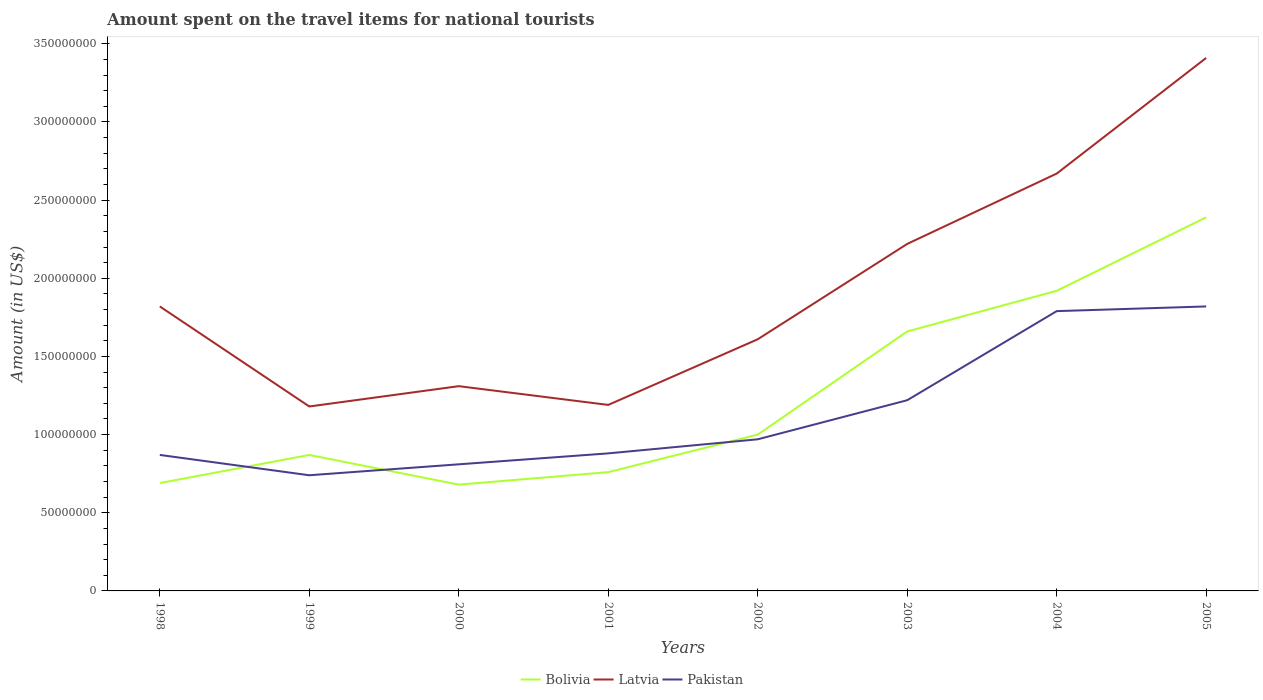Does the line corresponding to Bolivia intersect with the line corresponding to Pakistan?
Offer a very short reply. Yes. Is the number of lines equal to the number of legend labels?
Make the answer very short. Yes. Across all years, what is the maximum amount spent on the travel items for national tourists in Latvia?
Keep it short and to the point. 1.18e+08. What is the total amount spent on the travel items for national tourists in Latvia in the graph?
Offer a terse response. -4.30e+07. What is the difference between the highest and the second highest amount spent on the travel items for national tourists in Pakistan?
Ensure brevity in your answer.  1.08e+08. What is the difference between the highest and the lowest amount spent on the travel items for national tourists in Bolivia?
Your response must be concise. 3. How many lines are there?
Your response must be concise. 3. How many years are there in the graph?
Your response must be concise. 8. How many legend labels are there?
Your answer should be very brief. 3. What is the title of the graph?
Keep it short and to the point. Amount spent on the travel items for national tourists. What is the label or title of the X-axis?
Give a very brief answer. Years. What is the Amount (in US$) in Bolivia in 1998?
Your response must be concise. 6.90e+07. What is the Amount (in US$) in Latvia in 1998?
Make the answer very short. 1.82e+08. What is the Amount (in US$) of Pakistan in 1998?
Make the answer very short. 8.70e+07. What is the Amount (in US$) in Bolivia in 1999?
Your answer should be very brief. 8.70e+07. What is the Amount (in US$) of Latvia in 1999?
Your answer should be compact. 1.18e+08. What is the Amount (in US$) in Pakistan in 1999?
Your answer should be very brief. 7.40e+07. What is the Amount (in US$) in Bolivia in 2000?
Provide a short and direct response. 6.80e+07. What is the Amount (in US$) in Latvia in 2000?
Your response must be concise. 1.31e+08. What is the Amount (in US$) of Pakistan in 2000?
Provide a succinct answer. 8.10e+07. What is the Amount (in US$) in Bolivia in 2001?
Your response must be concise. 7.60e+07. What is the Amount (in US$) of Latvia in 2001?
Provide a short and direct response. 1.19e+08. What is the Amount (in US$) in Pakistan in 2001?
Offer a very short reply. 8.80e+07. What is the Amount (in US$) of Latvia in 2002?
Give a very brief answer. 1.61e+08. What is the Amount (in US$) in Pakistan in 2002?
Provide a succinct answer. 9.70e+07. What is the Amount (in US$) of Bolivia in 2003?
Your response must be concise. 1.66e+08. What is the Amount (in US$) of Latvia in 2003?
Offer a very short reply. 2.22e+08. What is the Amount (in US$) of Pakistan in 2003?
Provide a short and direct response. 1.22e+08. What is the Amount (in US$) in Bolivia in 2004?
Offer a very short reply. 1.92e+08. What is the Amount (in US$) of Latvia in 2004?
Your answer should be compact. 2.67e+08. What is the Amount (in US$) in Pakistan in 2004?
Provide a succinct answer. 1.79e+08. What is the Amount (in US$) of Bolivia in 2005?
Your answer should be compact. 2.39e+08. What is the Amount (in US$) of Latvia in 2005?
Your response must be concise. 3.41e+08. What is the Amount (in US$) in Pakistan in 2005?
Offer a very short reply. 1.82e+08. Across all years, what is the maximum Amount (in US$) in Bolivia?
Give a very brief answer. 2.39e+08. Across all years, what is the maximum Amount (in US$) in Latvia?
Your response must be concise. 3.41e+08. Across all years, what is the maximum Amount (in US$) in Pakistan?
Your response must be concise. 1.82e+08. Across all years, what is the minimum Amount (in US$) in Bolivia?
Provide a short and direct response. 6.80e+07. Across all years, what is the minimum Amount (in US$) in Latvia?
Provide a succinct answer. 1.18e+08. Across all years, what is the minimum Amount (in US$) of Pakistan?
Make the answer very short. 7.40e+07. What is the total Amount (in US$) of Bolivia in the graph?
Your response must be concise. 9.97e+08. What is the total Amount (in US$) in Latvia in the graph?
Ensure brevity in your answer.  1.54e+09. What is the total Amount (in US$) in Pakistan in the graph?
Provide a succinct answer. 9.10e+08. What is the difference between the Amount (in US$) of Bolivia in 1998 and that in 1999?
Provide a short and direct response. -1.80e+07. What is the difference between the Amount (in US$) of Latvia in 1998 and that in 1999?
Make the answer very short. 6.40e+07. What is the difference between the Amount (in US$) of Pakistan in 1998 and that in 1999?
Provide a short and direct response. 1.30e+07. What is the difference between the Amount (in US$) in Bolivia in 1998 and that in 2000?
Ensure brevity in your answer.  1.00e+06. What is the difference between the Amount (in US$) of Latvia in 1998 and that in 2000?
Your answer should be very brief. 5.10e+07. What is the difference between the Amount (in US$) in Bolivia in 1998 and that in 2001?
Make the answer very short. -7.00e+06. What is the difference between the Amount (in US$) of Latvia in 1998 and that in 2001?
Ensure brevity in your answer.  6.30e+07. What is the difference between the Amount (in US$) in Pakistan in 1998 and that in 2001?
Make the answer very short. -1.00e+06. What is the difference between the Amount (in US$) in Bolivia in 1998 and that in 2002?
Provide a succinct answer. -3.10e+07. What is the difference between the Amount (in US$) in Latvia in 1998 and that in 2002?
Make the answer very short. 2.10e+07. What is the difference between the Amount (in US$) in Pakistan in 1998 and that in 2002?
Offer a terse response. -1.00e+07. What is the difference between the Amount (in US$) in Bolivia in 1998 and that in 2003?
Keep it short and to the point. -9.70e+07. What is the difference between the Amount (in US$) of Latvia in 1998 and that in 2003?
Provide a succinct answer. -4.00e+07. What is the difference between the Amount (in US$) in Pakistan in 1998 and that in 2003?
Offer a terse response. -3.50e+07. What is the difference between the Amount (in US$) of Bolivia in 1998 and that in 2004?
Your response must be concise. -1.23e+08. What is the difference between the Amount (in US$) of Latvia in 1998 and that in 2004?
Keep it short and to the point. -8.50e+07. What is the difference between the Amount (in US$) in Pakistan in 1998 and that in 2004?
Your answer should be compact. -9.20e+07. What is the difference between the Amount (in US$) in Bolivia in 1998 and that in 2005?
Give a very brief answer. -1.70e+08. What is the difference between the Amount (in US$) in Latvia in 1998 and that in 2005?
Keep it short and to the point. -1.59e+08. What is the difference between the Amount (in US$) of Pakistan in 1998 and that in 2005?
Offer a terse response. -9.50e+07. What is the difference between the Amount (in US$) in Bolivia in 1999 and that in 2000?
Keep it short and to the point. 1.90e+07. What is the difference between the Amount (in US$) in Latvia in 1999 and that in 2000?
Your answer should be compact. -1.30e+07. What is the difference between the Amount (in US$) in Pakistan in 1999 and that in 2000?
Keep it short and to the point. -7.00e+06. What is the difference between the Amount (in US$) of Bolivia in 1999 and that in 2001?
Your response must be concise. 1.10e+07. What is the difference between the Amount (in US$) of Latvia in 1999 and that in 2001?
Offer a terse response. -1.00e+06. What is the difference between the Amount (in US$) in Pakistan in 1999 and that in 2001?
Make the answer very short. -1.40e+07. What is the difference between the Amount (in US$) in Bolivia in 1999 and that in 2002?
Ensure brevity in your answer.  -1.30e+07. What is the difference between the Amount (in US$) of Latvia in 1999 and that in 2002?
Give a very brief answer. -4.30e+07. What is the difference between the Amount (in US$) of Pakistan in 1999 and that in 2002?
Your answer should be compact. -2.30e+07. What is the difference between the Amount (in US$) in Bolivia in 1999 and that in 2003?
Your answer should be very brief. -7.90e+07. What is the difference between the Amount (in US$) in Latvia in 1999 and that in 2003?
Your answer should be compact. -1.04e+08. What is the difference between the Amount (in US$) in Pakistan in 1999 and that in 2003?
Your answer should be very brief. -4.80e+07. What is the difference between the Amount (in US$) of Bolivia in 1999 and that in 2004?
Give a very brief answer. -1.05e+08. What is the difference between the Amount (in US$) of Latvia in 1999 and that in 2004?
Your answer should be very brief. -1.49e+08. What is the difference between the Amount (in US$) of Pakistan in 1999 and that in 2004?
Offer a very short reply. -1.05e+08. What is the difference between the Amount (in US$) of Bolivia in 1999 and that in 2005?
Ensure brevity in your answer.  -1.52e+08. What is the difference between the Amount (in US$) of Latvia in 1999 and that in 2005?
Ensure brevity in your answer.  -2.23e+08. What is the difference between the Amount (in US$) of Pakistan in 1999 and that in 2005?
Make the answer very short. -1.08e+08. What is the difference between the Amount (in US$) of Bolivia in 2000 and that in 2001?
Offer a very short reply. -8.00e+06. What is the difference between the Amount (in US$) of Latvia in 2000 and that in 2001?
Provide a short and direct response. 1.20e+07. What is the difference between the Amount (in US$) in Pakistan in 2000 and that in 2001?
Make the answer very short. -7.00e+06. What is the difference between the Amount (in US$) of Bolivia in 2000 and that in 2002?
Ensure brevity in your answer.  -3.20e+07. What is the difference between the Amount (in US$) of Latvia in 2000 and that in 2002?
Ensure brevity in your answer.  -3.00e+07. What is the difference between the Amount (in US$) of Pakistan in 2000 and that in 2002?
Provide a short and direct response. -1.60e+07. What is the difference between the Amount (in US$) in Bolivia in 2000 and that in 2003?
Give a very brief answer. -9.80e+07. What is the difference between the Amount (in US$) in Latvia in 2000 and that in 2003?
Provide a succinct answer. -9.10e+07. What is the difference between the Amount (in US$) in Pakistan in 2000 and that in 2003?
Give a very brief answer. -4.10e+07. What is the difference between the Amount (in US$) in Bolivia in 2000 and that in 2004?
Your answer should be very brief. -1.24e+08. What is the difference between the Amount (in US$) of Latvia in 2000 and that in 2004?
Your response must be concise. -1.36e+08. What is the difference between the Amount (in US$) in Pakistan in 2000 and that in 2004?
Your response must be concise. -9.80e+07. What is the difference between the Amount (in US$) in Bolivia in 2000 and that in 2005?
Your answer should be very brief. -1.71e+08. What is the difference between the Amount (in US$) of Latvia in 2000 and that in 2005?
Offer a very short reply. -2.10e+08. What is the difference between the Amount (in US$) of Pakistan in 2000 and that in 2005?
Keep it short and to the point. -1.01e+08. What is the difference between the Amount (in US$) in Bolivia in 2001 and that in 2002?
Provide a succinct answer. -2.40e+07. What is the difference between the Amount (in US$) in Latvia in 2001 and that in 2002?
Make the answer very short. -4.20e+07. What is the difference between the Amount (in US$) in Pakistan in 2001 and that in 2002?
Ensure brevity in your answer.  -9.00e+06. What is the difference between the Amount (in US$) in Bolivia in 2001 and that in 2003?
Your answer should be compact. -9.00e+07. What is the difference between the Amount (in US$) in Latvia in 2001 and that in 2003?
Make the answer very short. -1.03e+08. What is the difference between the Amount (in US$) in Pakistan in 2001 and that in 2003?
Make the answer very short. -3.40e+07. What is the difference between the Amount (in US$) in Bolivia in 2001 and that in 2004?
Offer a terse response. -1.16e+08. What is the difference between the Amount (in US$) of Latvia in 2001 and that in 2004?
Your response must be concise. -1.48e+08. What is the difference between the Amount (in US$) in Pakistan in 2001 and that in 2004?
Offer a terse response. -9.10e+07. What is the difference between the Amount (in US$) in Bolivia in 2001 and that in 2005?
Provide a short and direct response. -1.63e+08. What is the difference between the Amount (in US$) of Latvia in 2001 and that in 2005?
Offer a very short reply. -2.22e+08. What is the difference between the Amount (in US$) in Pakistan in 2001 and that in 2005?
Make the answer very short. -9.40e+07. What is the difference between the Amount (in US$) in Bolivia in 2002 and that in 2003?
Provide a succinct answer. -6.60e+07. What is the difference between the Amount (in US$) of Latvia in 2002 and that in 2003?
Offer a very short reply. -6.10e+07. What is the difference between the Amount (in US$) in Pakistan in 2002 and that in 2003?
Provide a succinct answer. -2.50e+07. What is the difference between the Amount (in US$) in Bolivia in 2002 and that in 2004?
Your answer should be very brief. -9.20e+07. What is the difference between the Amount (in US$) in Latvia in 2002 and that in 2004?
Provide a short and direct response. -1.06e+08. What is the difference between the Amount (in US$) of Pakistan in 2002 and that in 2004?
Your response must be concise. -8.20e+07. What is the difference between the Amount (in US$) in Bolivia in 2002 and that in 2005?
Provide a short and direct response. -1.39e+08. What is the difference between the Amount (in US$) of Latvia in 2002 and that in 2005?
Your answer should be compact. -1.80e+08. What is the difference between the Amount (in US$) in Pakistan in 2002 and that in 2005?
Keep it short and to the point. -8.50e+07. What is the difference between the Amount (in US$) in Bolivia in 2003 and that in 2004?
Your response must be concise. -2.60e+07. What is the difference between the Amount (in US$) of Latvia in 2003 and that in 2004?
Give a very brief answer. -4.50e+07. What is the difference between the Amount (in US$) in Pakistan in 2003 and that in 2004?
Your answer should be compact. -5.70e+07. What is the difference between the Amount (in US$) in Bolivia in 2003 and that in 2005?
Offer a very short reply. -7.30e+07. What is the difference between the Amount (in US$) in Latvia in 2003 and that in 2005?
Give a very brief answer. -1.19e+08. What is the difference between the Amount (in US$) of Pakistan in 2003 and that in 2005?
Give a very brief answer. -6.00e+07. What is the difference between the Amount (in US$) of Bolivia in 2004 and that in 2005?
Your answer should be compact. -4.70e+07. What is the difference between the Amount (in US$) of Latvia in 2004 and that in 2005?
Your response must be concise. -7.40e+07. What is the difference between the Amount (in US$) in Pakistan in 2004 and that in 2005?
Make the answer very short. -3.00e+06. What is the difference between the Amount (in US$) in Bolivia in 1998 and the Amount (in US$) in Latvia in 1999?
Your answer should be compact. -4.90e+07. What is the difference between the Amount (in US$) in Bolivia in 1998 and the Amount (in US$) in Pakistan in 1999?
Ensure brevity in your answer.  -5.00e+06. What is the difference between the Amount (in US$) in Latvia in 1998 and the Amount (in US$) in Pakistan in 1999?
Your answer should be very brief. 1.08e+08. What is the difference between the Amount (in US$) in Bolivia in 1998 and the Amount (in US$) in Latvia in 2000?
Make the answer very short. -6.20e+07. What is the difference between the Amount (in US$) of Bolivia in 1998 and the Amount (in US$) of Pakistan in 2000?
Make the answer very short. -1.20e+07. What is the difference between the Amount (in US$) of Latvia in 1998 and the Amount (in US$) of Pakistan in 2000?
Your answer should be compact. 1.01e+08. What is the difference between the Amount (in US$) in Bolivia in 1998 and the Amount (in US$) in Latvia in 2001?
Your answer should be very brief. -5.00e+07. What is the difference between the Amount (in US$) in Bolivia in 1998 and the Amount (in US$) in Pakistan in 2001?
Provide a succinct answer. -1.90e+07. What is the difference between the Amount (in US$) in Latvia in 1998 and the Amount (in US$) in Pakistan in 2001?
Provide a short and direct response. 9.40e+07. What is the difference between the Amount (in US$) in Bolivia in 1998 and the Amount (in US$) in Latvia in 2002?
Provide a short and direct response. -9.20e+07. What is the difference between the Amount (in US$) in Bolivia in 1998 and the Amount (in US$) in Pakistan in 2002?
Your answer should be compact. -2.80e+07. What is the difference between the Amount (in US$) of Latvia in 1998 and the Amount (in US$) of Pakistan in 2002?
Your answer should be compact. 8.50e+07. What is the difference between the Amount (in US$) in Bolivia in 1998 and the Amount (in US$) in Latvia in 2003?
Provide a succinct answer. -1.53e+08. What is the difference between the Amount (in US$) in Bolivia in 1998 and the Amount (in US$) in Pakistan in 2003?
Give a very brief answer. -5.30e+07. What is the difference between the Amount (in US$) of Latvia in 1998 and the Amount (in US$) of Pakistan in 2003?
Your answer should be very brief. 6.00e+07. What is the difference between the Amount (in US$) in Bolivia in 1998 and the Amount (in US$) in Latvia in 2004?
Your response must be concise. -1.98e+08. What is the difference between the Amount (in US$) of Bolivia in 1998 and the Amount (in US$) of Pakistan in 2004?
Provide a short and direct response. -1.10e+08. What is the difference between the Amount (in US$) in Bolivia in 1998 and the Amount (in US$) in Latvia in 2005?
Provide a short and direct response. -2.72e+08. What is the difference between the Amount (in US$) in Bolivia in 1998 and the Amount (in US$) in Pakistan in 2005?
Make the answer very short. -1.13e+08. What is the difference between the Amount (in US$) in Latvia in 1998 and the Amount (in US$) in Pakistan in 2005?
Your answer should be compact. 0. What is the difference between the Amount (in US$) in Bolivia in 1999 and the Amount (in US$) in Latvia in 2000?
Make the answer very short. -4.40e+07. What is the difference between the Amount (in US$) in Latvia in 1999 and the Amount (in US$) in Pakistan in 2000?
Your answer should be very brief. 3.70e+07. What is the difference between the Amount (in US$) in Bolivia in 1999 and the Amount (in US$) in Latvia in 2001?
Offer a very short reply. -3.20e+07. What is the difference between the Amount (in US$) in Latvia in 1999 and the Amount (in US$) in Pakistan in 2001?
Your answer should be very brief. 3.00e+07. What is the difference between the Amount (in US$) in Bolivia in 1999 and the Amount (in US$) in Latvia in 2002?
Give a very brief answer. -7.40e+07. What is the difference between the Amount (in US$) in Bolivia in 1999 and the Amount (in US$) in Pakistan in 2002?
Make the answer very short. -1.00e+07. What is the difference between the Amount (in US$) in Latvia in 1999 and the Amount (in US$) in Pakistan in 2002?
Offer a very short reply. 2.10e+07. What is the difference between the Amount (in US$) of Bolivia in 1999 and the Amount (in US$) of Latvia in 2003?
Ensure brevity in your answer.  -1.35e+08. What is the difference between the Amount (in US$) in Bolivia in 1999 and the Amount (in US$) in Pakistan in 2003?
Your answer should be very brief. -3.50e+07. What is the difference between the Amount (in US$) of Latvia in 1999 and the Amount (in US$) of Pakistan in 2003?
Your answer should be very brief. -4.00e+06. What is the difference between the Amount (in US$) in Bolivia in 1999 and the Amount (in US$) in Latvia in 2004?
Your response must be concise. -1.80e+08. What is the difference between the Amount (in US$) in Bolivia in 1999 and the Amount (in US$) in Pakistan in 2004?
Keep it short and to the point. -9.20e+07. What is the difference between the Amount (in US$) of Latvia in 1999 and the Amount (in US$) of Pakistan in 2004?
Offer a very short reply. -6.10e+07. What is the difference between the Amount (in US$) in Bolivia in 1999 and the Amount (in US$) in Latvia in 2005?
Your response must be concise. -2.54e+08. What is the difference between the Amount (in US$) of Bolivia in 1999 and the Amount (in US$) of Pakistan in 2005?
Give a very brief answer. -9.50e+07. What is the difference between the Amount (in US$) in Latvia in 1999 and the Amount (in US$) in Pakistan in 2005?
Offer a terse response. -6.40e+07. What is the difference between the Amount (in US$) in Bolivia in 2000 and the Amount (in US$) in Latvia in 2001?
Provide a short and direct response. -5.10e+07. What is the difference between the Amount (in US$) in Bolivia in 2000 and the Amount (in US$) in Pakistan in 2001?
Provide a succinct answer. -2.00e+07. What is the difference between the Amount (in US$) in Latvia in 2000 and the Amount (in US$) in Pakistan in 2001?
Provide a succinct answer. 4.30e+07. What is the difference between the Amount (in US$) in Bolivia in 2000 and the Amount (in US$) in Latvia in 2002?
Ensure brevity in your answer.  -9.30e+07. What is the difference between the Amount (in US$) of Bolivia in 2000 and the Amount (in US$) of Pakistan in 2002?
Keep it short and to the point. -2.90e+07. What is the difference between the Amount (in US$) of Latvia in 2000 and the Amount (in US$) of Pakistan in 2002?
Offer a very short reply. 3.40e+07. What is the difference between the Amount (in US$) in Bolivia in 2000 and the Amount (in US$) in Latvia in 2003?
Make the answer very short. -1.54e+08. What is the difference between the Amount (in US$) of Bolivia in 2000 and the Amount (in US$) of Pakistan in 2003?
Keep it short and to the point. -5.40e+07. What is the difference between the Amount (in US$) in Latvia in 2000 and the Amount (in US$) in Pakistan in 2003?
Give a very brief answer. 9.00e+06. What is the difference between the Amount (in US$) of Bolivia in 2000 and the Amount (in US$) of Latvia in 2004?
Your answer should be compact. -1.99e+08. What is the difference between the Amount (in US$) in Bolivia in 2000 and the Amount (in US$) in Pakistan in 2004?
Ensure brevity in your answer.  -1.11e+08. What is the difference between the Amount (in US$) of Latvia in 2000 and the Amount (in US$) of Pakistan in 2004?
Your answer should be compact. -4.80e+07. What is the difference between the Amount (in US$) in Bolivia in 2000 and the Amount (in US$) in Latvia in 2005?
Offer a terse response. -2.73e+08. What is the difference between the Amount (in US$) of Bolivia in 2000 and the Amount (in US$) of Pakistan in 2005?
Offer a terse response. -1.14e+08. What is the difference between the Amount (in US$) in Latvia in 2000 and the Amount (in US$) in Pakistan in 2005?
Your response must be concise. -5.10e+07. What is the difference between the Amount (in US$) in Bolivia in 2001 and the Amount (in US$) in Latvia in 2002?
Your response must be concise. -8.50e+07. What is the difference between the Amount (in US$) in Bolivia in 2001 and the Amount (in US$) in Pakistan in 2002?
Provide a short and direct response. -2.10e+07. What is the difference between the Amount (in US$) in Latvia in 2001 and the Amount (in US$) in Pakistan in 2002?
Offer a very short reply. 2.20e+07. What is the difference between the Amount (in US$) of Bolivia in 2001 and the Amount (in US$) of Latvia in 2003?
Your response must be concise. -1.46e+08. What is the difference between the Amount (in US$) in Bolivia in 2001 and the Amount (in US$) in Pakistan in 2003?
Keep it short and to the point. -4.60e+07. What is the difference between the Amount (in US$) in Bolivia in 2001 and the Amount (in US$) in Latvia in 2004?
Ensure brevity in your answer.  -1.91e+08. What is the difference between the Amount (in US$) in Bolivia in 2001 and the Amount (in US$) in Pakistan in 2004?
Your answer should be compact. -1.03e+08. What is the difference between the Amount (in US$) of Latvia in 2001 and the Amount (in US$) of Pakistan in 2004?
Ensure brevity in your answer.  -6.00e+07. What is the difference between the Amount (in US$) of Bolivia in 2001 and the Amount (in US$) of Latvia in 2005?
Provide a short and direct response. -2.65e+08. What is the difference between the Amount (in US$) of Bolivia in 2001 and the Amount (in US$) of Pakistan in 2005?
Provide a short and direct response. -1.06e+08. What is the difference between the Amount (in US$) of Latvia in 2001 and the Amount (in US$) of Pakistan in 2005?
Offer a very short reply. -6.30e+07. What is the difference between the Amount (in US$) in Bolivia in 2002 and the Amount (in US$) in Latvia in 2003?
Keep it short and to the point. -1.22e+08. What is the difference between the Amount (in US$) in Bolivia in 2002 and the Amount (in US$) in Pakistan in 2003?
Provide a succinct answer. -2.20e+07. What is the difference between the Amount (in US$) in Latvia in 2002 and the Amount (in US$) in Pakistan in 2003?
Keep it short and to the point. 3.90e+07. What is the difference between the Amount (in US$) in Bolivia in 2002 and the Amount (in US$) in Latvia in 2004?
Provide a short and direct response. -1.67e+08. What is the difference between the Amount (in US$) of Bolivia in 2002 and the Amount (in US$) of Pakistan in 2004?
Offer a very short reply. -7.90e+07. What is the difference between the Amount (in US$) of Latvia in 2002 and the Amount (in US$) of Pakistan in 2004?
Make the answer very short. -1.80e+07. What is the difference between the Amount (in US$) of Bolivia in 2002 and the Amount (in US$) of Latvia in 2005?
Offer a very short reply. -2.41e+08. What is the difference between the Amount (in US$) in Bolivia in 2002 and the Amount (in US$) in Pakistan in 2005?
Make the answer very short. -8.20e+07. What is the difference between the Amount (in US$) in Latvia in 2002 and the Amount (in US$) in Pakistan in 2005?
Make the answer very short. -2.10e+07. What is the difference between the Amount (in US$) in Bolivia in 2003 and the Amount (in US$) in Latvia in 2004?
Ensure brevity in your answer.  -1.01e+08. What is the difference between the Amount (in US$) of Bolivia in 2003 and the Amount (in US$) of Pakistan in 2004?
Ensure brevity in your answer.  -1.30e+07. What is the difference between the Amount (in US$) in Latvia in 2003 and the Amount (in US$) in Pakistan in 2004?
Ensure brevity in your answer.  4.30e+07. What is the difference between the Amount (in US$) of Bolivia in 2003 and the Amount (in US$) of Latvia in 2005?
Keep it short and to the point. -1.75e+08. What is the difference between the Amount (in US$) in Bolivia in 2003 and the Amount (in US$) in Pakistan in 2005?
Your response must be concise. -1.60e+07. What is the difference between the Amount (in US$) in Latvia in 2003 and the Amount (in US$) in Pakistan in 2005?
Make the answer very short. 4.00e+07. What is the difference between the Amount (in US$) in Bolivia in 2004 and the Amount (in US$) in Latvia in 2005?
Your answer should be compact. -1.49e+08. What is the difference between the Amount (in US$) in Latvia in 2004 and the Amount (in US$) in Pakistan in 2005?
Ensure brevity in your answer.  8.50e+07. What is the average Amount (in US$) of Bolivia per year?
Your answer should be compact. 1.25e+08. What is the average Amount (in US$) in Latvia per year?
Give a very brief answer. 1.93e+08. What is the average Amount (in US$) of Pakistan per year?
Give a very brief answer. 1.14e+08. In the year 1998, what is the difference between the Amount (in US$) in Bolivia and Amount (in US$) in Latvia?
Give a very brief answer. -1.13e+08. In the year 1998, what is the difference between the Amount (in US$) in Bolivia and Amount (in US$) in Pakistan?
Your answer should be very brief. -1.80e+07. In the year 1998, what is the difference between the Amount (in US$) in Latvia and Amount (in US$) in Pakistan?
Offer a very short reply. 9.50e+07. In the year 1999, what is the difference between the Amount (in US$) of Bolivia and Amount (in US$) of Latvia?
Offer a very short reply. -3.10e+07. In the year 1999, what is the difference between the Amount (in US$) in Bolivia and Amount (in US$) in Pakistan?
Keep it short and to the point. 1.30e+07. In the year 1999, what is the difference between the Amount (in US$) of Latvia and Amount (in US$) of Pakistan?
Provide a short and direct response. 4.40e+07. In the year 2000, what is the difference between the Amount (in US$) in Bolivia and Amount (in US$) in Latvia?
Provide a short and direct response. -6.30e+07. In the year 2000, what is the difference between the Amount (in US$) of Bolivia and Amount (in US$) of Pakistan?
Your answer should be very brief. -1.30e+07. In the year 2000, what is the difference between the Amount (in US$) in Latvia and Amount (in US$) in Pakistan?
Make the answer very short. 5.00e+07. In the year 2001, what is the difference between the Amount (in US$) in Bolivia and Amount (in US$) in Latvia?
Ensure brevity in your answer.  -4.30e+07. In the year 2001, what is the difference between the Amount (in US$) of Bolivia and Amount (in US$) of Pakistan?
Ensure brevity in your answer.  -1.20e+07. In the year 2001, what is the difference between the Amount (in US$) in Latvia and Amount (in US$) in Pakistan?
Make the answer very short. 3.10e+07. In the year 2002, what is the difference between the Amount (in US$) of Bolivia and Amount (in US$) of Latvia?
Offer a very short reply. -6.10e+07. In the year 2002, what is the difference between the Amount (in US$) of Bolivia and Amount (in US$) of Pakistan?
Your response must be concise. 3.00e+06. In the year 2002, what is the difference between the Amount (in US$) in Latvia and Amount (in US$) in Pakistan?
Make the answer very short. 6.40e+07. In the year 2003, what is the difference between the Amount (in US$) in Bolivia and Amount (in US$) in Latvia?
Your answer should be compact. -5.60e+07. In the year 2003, what is the difference between the Amount (in US$) of Bolivia and Amount (in US$) of Pakistan?
Make the answer very short. 4.40e+07. In the year 2004, what is the difference between the Amount (in US$) in Bolivia and Amount (in US$) in Latvia?
Ensure brevity in your answer.  -7.50e+07. In the year 2004, what is the difference between the Amount (in US$) of Bolivia and Amount (in US$) of Pakistan?
Provide a short and direct response. 1.30e+07. In the year 2004, what is the difference between the Amount (in US$) of Latvia and Amount (in US$) of Pakistan?
Make the answer very short. 8.80e+07. In the year 2005, what is the difference between the Amount (in US$) in Bolivia and Amount (in US$) in Latvia?
Offer a very short reply. -1.02e+08. In the year 2005, what is the difference between the Amount (in US$) in Bolivia and Amount (in US$) in Pakistan?
Your response must be concise. 5.70e+07. In the year 2005, what is the difference between the Amount (in US$) of Latvia and Amount (in US$) of Pakistan?
Ensure brevity in your answer.  1.59e+08. What is the ratio of the Amount (in US$) in Bolivia in 1998 to that in 1999?
Ensure brevity in your answer.  0.79. What is the ratio of the Amount (in US$) in Latvia in 1998 to that in 1999?
Ensure brevity in your answer.  1.54. What is the ratio of the Amount (in US$) of Pakistan in 1998 to that in 1999?
Your response must be concise. 1.18. What is the ratio of the Amount (in US$) of Bolivia in 1998 to that in 2000?
Offer a very short reply. 1.01. What is the ratio of the Amount (in US$) of Latvia in 1998 to that in 2000?
Make the answer very short. 1.39. What is the ratio of the Amount (in US$) in Pakistan in 1998 to that in 2000?
Your answer should be compact. 1.07. What is the ratio of the Amount (in US$) in Bolivia in 1998 to that in 2001?
Provide a short and direct response. 0.91. What is the ratio of the Amount (in US$) in Latvia in 1998 to that in 2001?
Your response must be concise. 1.53. What is the ratio of the Amount (in US$) in Pakistan in 1998 to that in 2001?
Make the answer very short. 0.99. What is the ratio of the Amount (in US$) of Bolivia in 1998 to that in 2002?
Ensure brevity in your answer.  0.69. What is the ratio of the Amount (in US$) in Latvia in 1998 to that in 2002?
Make the answer very short. 1.13. What is the ratio of the Amount (in US$) in Pakistan in 1998 to that in 2002?
Provide a succinct answer. 0.9. What is the ratio of the Amount (in US$) in Bolivia in 1998 to that in 2003?
Your response must be concise. 0.42. What is the ratio of the Amount (in US$) of Latvia in 1998 to that in 2003?
Your answer should be very brief. 0.82. What is the ratio of the Amount (in US$) in Pakistan in 1998 to that in 2003?
Your answer should be compact. 0.71. What is the ratio of the Amount (in US$) in Bolivia in 1998 to that in 2004?
Make the answer very short. 0.36. What is the ratio of the Amount (in US$) of Latvia in 1998 to that in 2004?
Make the answer very short. 0.68. What is the ratio of the Amount (in US$) of Pakistan in 1998 to that in 2004?
Ensure brevity in your answer.  0.49. What is the ratio of the Amount (in US$) of Bolivia in 1998 to that in 2005?
Keep it short and to the point. 0.29. What is the ratio of the Amount (in US$) in Latvia in 1998 to that in 2005?
Your response must be concise. 0.53. What is the ratio of the Amount (in US$) of Pakistan in 1998 to that in 2005?
Your answer should be very brief. 0.48. What is the ratio of the Amount (in US$) of Bolivia in 1999 to that in 2000?
Give a very brief answer. 1.28. What is the ratio of the Amount (in US$) in Latvia in 1999 to that in 2000?
Your answer should be very brief. 0.9. What is the ratio of the Amount (in US$) of Pakistan in 1999 to that in 2000?
Your answer should be compact. 0.91. What is the ratio of the Amount (in US$) in Bolivia in 1999 to that in 2001?
Offer a very short reply. 1.14. What is the ratio of the Amount (in US$) of Latvia in 1999 to that in 2001?
Make the answer very short. 0.99. What is the ratio of the Amount (in US$) of Pakistan in 1999 to that in 2001?
Ensure brevity in your answer.  0.84. What is the ratio of the Amount (in US$) in Bolivia in 1999 to that in 2002?
Offer a terse response. 0.87. What is the ratio of the Amount (in US$) of Latvia in 1999 to that in 2002?
Your response must be concise. 0.73. What is the ratio of the Amount (in US$) of Pakistan in 1999 to that in 2002?
Your response must be concise. 0.76. What is the ratio of the Amount (in US$) of Bolivia in 1999 to that in 2003?
Keep it short and to the point. 0.52. What is the ratio of the Amount (in US$) in Latvia in 1999 to that in 2003?
Your answer should be very brief. 0.53. What is the ratio of the Amount (in US$) in Pakistan in 1999 to that in 2003?
Offer a terse response. 0.61. What is the ratio of the Amount (in US$) of Bolivia in 1999 to that in 2004?
Provide a succinct answer. 0.45. What is the ratio of the Amount (in US$) in Latvia in 1999 to that in 2004?
Provide a succinct answer. 0.44. What is the ratio of the Amount (in US$) of Pakistan in 1999 to that in 2004?
Your answer should be very brief. 0.41. What is the ratio of the Amount (in US$) in Bolivia in 1999 to that in 2005?
Give a very brief answer. 0.36. What is the ratio of the Amount (in US$) of Latvia in 1999 to that in 2005?
Your answer should be very brief. 0.35. What is the ratio of the Amount (in US$) of Pakistan in 1999 to that in 2005?
Your response must be concise. 0.41. What is the ratio of the Amount (in US$) of Bolivia in 2000 to that in 2001?
Your answer should be very brief. 0.89. What is the ratio of the Amount (in US$) of Latvia in 2000 to that in 2001?
Your answer should be very brief. 1.1. What is the ratio of the Amount (in US$) in Pakistan in 2000 to that in 2001?
Ensure brevity in your answer.  0.92. What is the ratio of the Amount (in US$) in Bolivia in 2000 to that in 2002?
Your answer should be very brief. 0.68. What is the ratio of the Amount (in US$) in Latvia in 2000 to that in 2002?
Your response must be concise. 0.81. What is the ratio of the Amount (in US$) in Pakistan in 2000 to that in 2002?
Offer a very short reply. 0.84. What is the ratio of the Amount (in US$) in Bolivia in 2000 to that in 2003?
Give a very brief answer. 0.41. What is the ratio of the Amount (in US$) of Latvia in 2000 to that in 2003?
Your answer should be very brief. 0.59. What is the ratio of the Amount (in US$) of Pakistan in 2000 to that in 2003?
Keep it short and to the point. 0.66. What is the ratio of the Amount (in US$) in Bolivia in 2000 to that in 2004?
Ensure brevity in your answer.  0.35. What is the ratio of the Amount (in US$) of Latvia in 2000 to that in 2004?
Keep it short and to the point. 0.49. What is the ratio of the Amount (in US$) in Pakistan in 2000 to that in 2004?
Make the answer very short. 0.45. What is the ratio of the Amount (in US$) of Bolivia in 2000 to that in 2005?
Ensure brevity in your answer.  0.28. What is the ratio of the Amount (in US$) in Latvia in 2000 to that in 2005?
Your response must be concise. 0.38. What is the ratio of the Amount (in US$) in Pakistan in 2000 to that in 2005?
Give a very brief answer. 0.45. What is the ratio of the Amount (in US$) of Bolivia in 2001 to that in 2002?
Provide a short and direct response. 0.76. What is the ratio of the Amount (in US$) of Latvia in 2001 to that in 2002?
Offer a very short reply. 0.74. What is the ratio of the Amount (in US$) in Pakistan in 2001 to that in 2002?
Give a very brief answer. 0.91. What is the ratio of the Amount (in US$) of Bolivia in 2001 to that in 2003?
Provide a succinct answer. 0.46. What is the ratio of the Amount (in US$) of Latvia in 2001 to that in 2003?
Provide a succinct answer. 0.54. What is the ratio of the Amount (in US$) in Pakistan in 2001 to that in 2003?
Your answer should be compact. 0.72. What is the ratio of the Amount (in US$) in Bolivia in 2001 to that in 2004?
Provide a short and direct response. 0.4. What is the ratio of the Amount (in US$) in Latvia in 2001 to that in 2004?
Offer a terse response. 0.45. What is the ratio of the Amount (in US$) of Pakistan in 2001 to that in 2004?
Make the answer very short. 0.49. What is the ratio of the Amount (in US$) in Bolivia in 2001 to that in 2005?
Keep it short and to the point. 0.32. What is the ratio of the Amount (in US$) of Latvia in 2001 to that in 2005?
Offer a terse response. 0.35. What is the ratio of the Amount (in US$) of Pakistan in 2001 to that in 2005?
Ensure brevity in your answer.  0.48. What is the ratio of the Amount (in US$) of Bolivia in 2002 to that in 2003?
Keep it short and to the point. 0.6. What is the ratio of the Amount (in US$) of Latvia in 2002 to that in 2003?
Provide a short and direct response. 0.73. What is the ratio of the Amount (in US$) of Pakistan in 2002 to that in 2003?
Offer a terse response. 0.8. What is the ratio of the Amount (in US$) in Bolivia in 2002 to that in 2004?
Provide a succinct answer. 0.52. What is the ratio of the Amount (in US$) of Latvia in 2002 to that in 2004?
Keep it short and to the point. 0.6. What is the ratio of the Amount (in US$) of Pakistan in 2002 to that in 2004?
Provide a short and direct response. 0.54. What is the ratio of the Amount (in US$) in Bolivia in 2002 to that in 2005?
Make the answer very short. 0.42. What is the ratio of the Amount (in US$) of Latvia in 2002 to that in 2005?
Provide a short and direct response. 0.47. What is the ratio of the Amount (in US$) of Pakistan in 2002 to that in 2005?
Your response must be concise. 0.53. What is the ratio of the Amount (in US$) of Bolivia in 2003 to that in 2004?
Provide a succinct answer. 0.86. What is the ratio of the Amount (in US$) in Latvia in 2003 to that in 2004?
Offer a terse response. 0.83. What is the ratio of the Amount (in US$) in Pakistan in 2003 to that in 2004?
Your response must be concise. 0.68. What is the ratio of the Amount (in US$) of Bolivia in 2003 to that in 2005?
Give a very brief answer. 0.69. What is the ratio of the Amount (in US$) of Latvia in 2003 to that in 2005?
Make the answer very short. 0.65. What is the ratio of the Amount (in US$) of Pakistan in 2003 to that in 2005?
Your answer should be compact. 0.67. What is the ratio of the Amount (in US$) in Bolivia in 2004 to that in 2005?
Offer a very short reply. 0.8. What is the ratio of the Amount (in US$) in Latvia in 2004 to that in 2005?
Ensure brevity in your answer.  0.78. What is the ratio of the Amount (in US$) of Pakistan in 2004 to that in 2005?
Give a very brief answer. 0.98. What is the difference between the highest and the second highest Amount (in US$) of Bolivia?
Give a very brief answer. 4.70e+07. What is the difference between the highest and the second highest Amount (in US$) in Latvia?
Provide a short and direct response. 7.40e+07. What is the difference between the highest and the second highest Amount (in US$) in Pakistan?
Offer a very short reply. 3.00e+06. What is the difference between the highest and the lowest Amount (in US$) of Bolivia?
Your answer should be very brief. 1.71e+08. What is the difference between the highest and the lowest Amount (in US$) of Latvia?
Offer a very short reply. 2.23e+08. What is the difference between the highest and the lowest Amount (in US$) of Pakistan?
Give a very brief answer. 1.08e+08. 